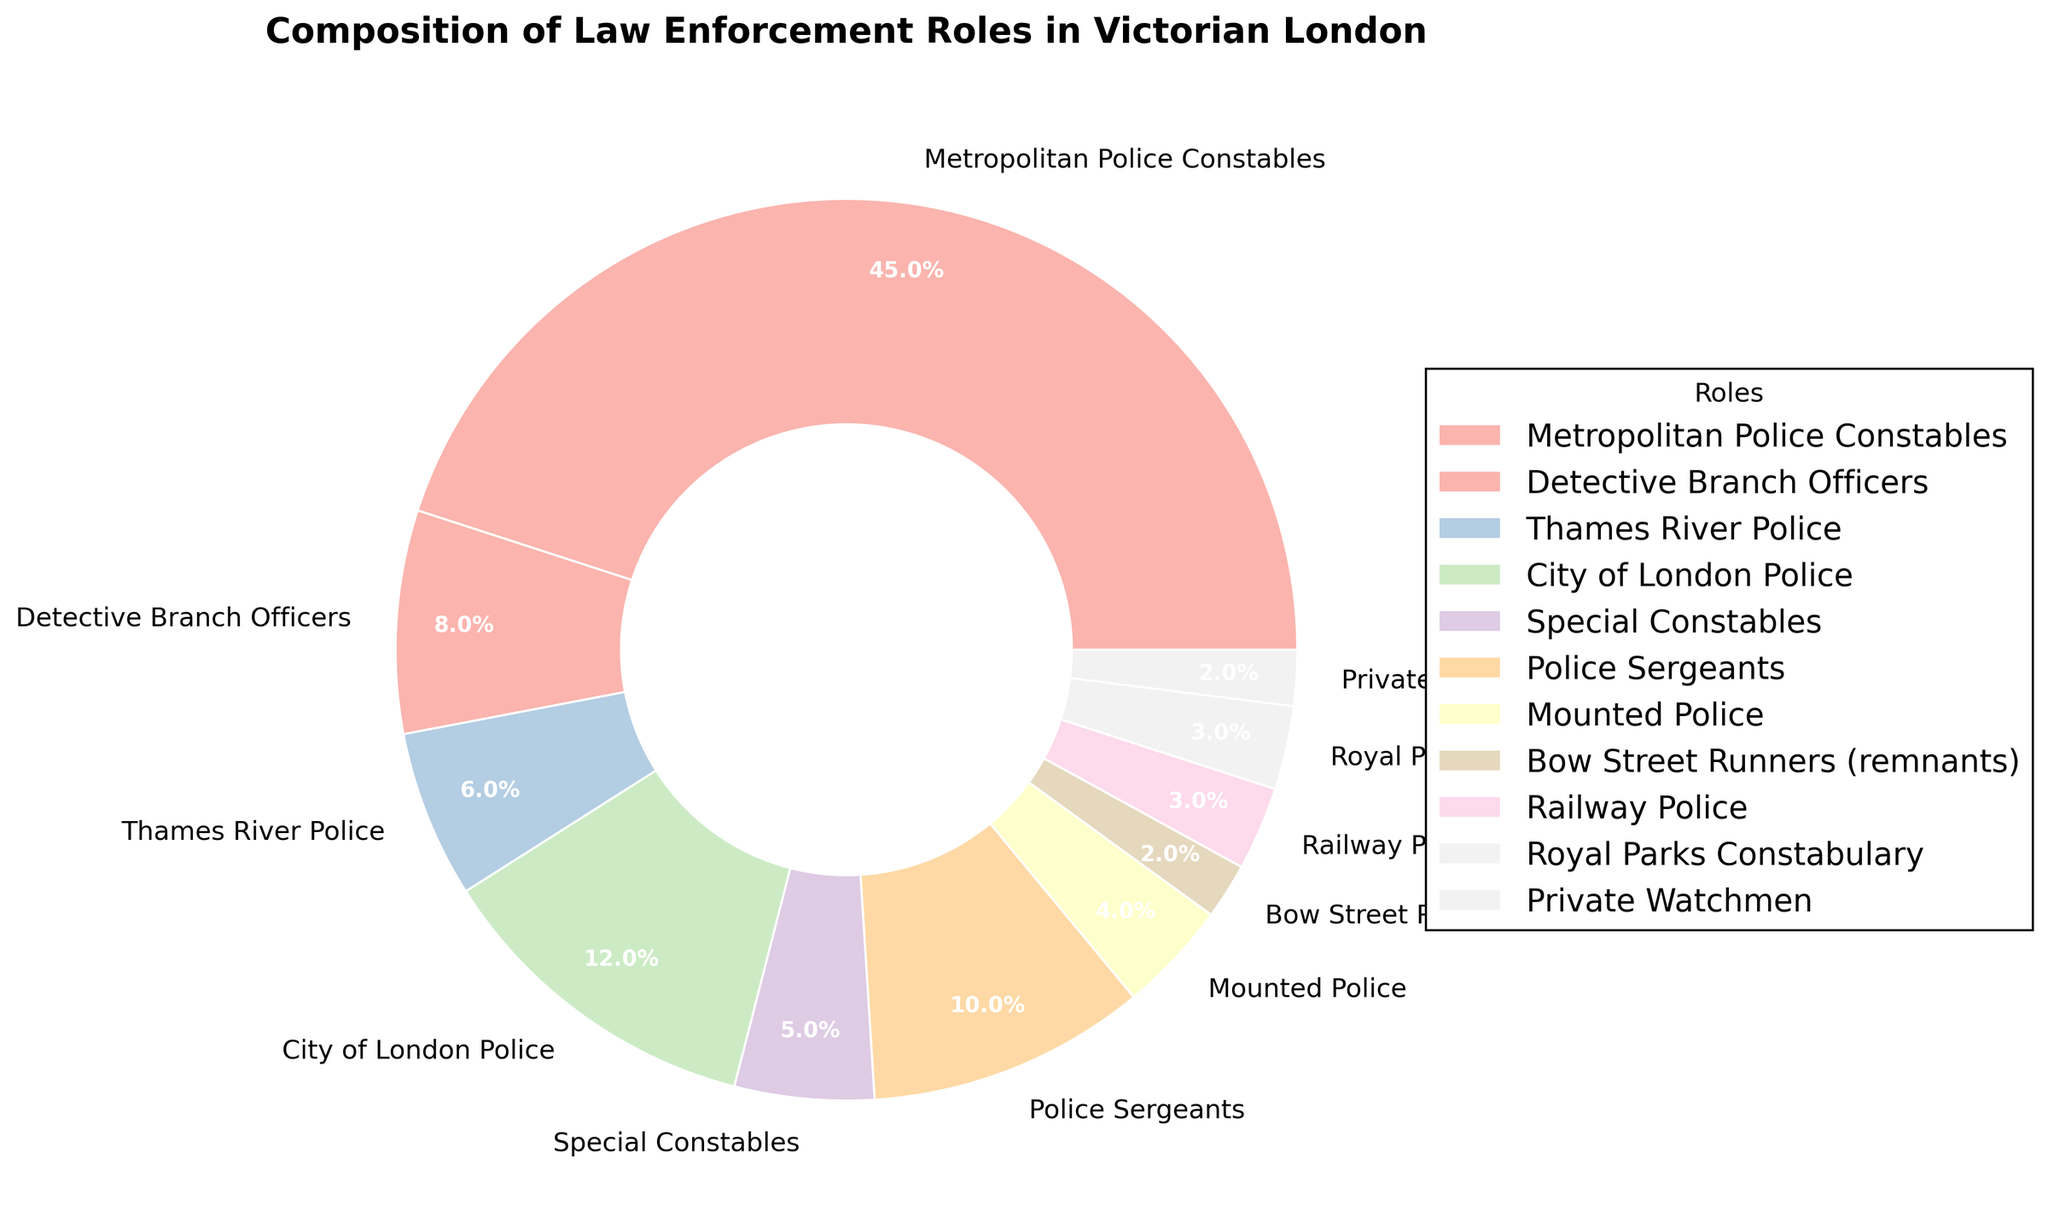What percentage of law enforcement roles do Metropolitan Police Constables and Police Sergeants together constitute? Combine the percentages of Metropolitan Police Constables (45%) and Police Sergeants (10%). Sum them up: 45% + 10% = 55%.
Answer: 55% Which role has the smallest proportion in the chart? How much is it? Identify the role with the smallest percentage, which is Bow Street Runners (remnants) with 2%.
Answer: Bow Street Runners (remnants), 2% How does the percentage of City of London Police compare to that of Thames River Police? The percentage for City of London Police is 12%, and for Thames River Police, it is 6%. Comparatively, City of London Police is twice that of Thames River Police: 12% > 6%.
Answer: City of London Police is twice the percentage of Thames River Police What is the difference in percentage between Detective Branch Officers and Special Constables? Subtract the percentage of Special Constables (5%) from Detective Branch Officers (8%). Difference: 8% - 5% = 3%.
Answer: 3% Which role has a higher percentage: Railway Police or Royal Parks Constabulary? Compare the percentages of Railway Police and Royal Parks Constabulary, both of which have 3%. Thus, they are equal.
Answer: They are equal What is the total percentage of all roles that constitute less than 5% each? Sum the percentages of roles with less than 5% each: Thames River Police (6%), Special Constables (5%), Mounted Police (4%), Bow Street Runners (remnants) (2%), Railway Police (3%), Royal Parks Constabulary (3%), Private Watchmen (2%). Sum: 2% + 3% + 2% = 7%. 6% and 5% are not included as they're not less than 5%.
Answer: 10% What is the average percentage of the Detective Branch Officers, Thames River Police, and City of London Police? Sum the percentages of these roles: Detective Branch Officers (8%), Thames River Police (6%), City of London Police (12%). Then, divide by the number of roles (3). Average: (8% + 6% + 12%) / 3 = 26% / 3 ≈ 8.67%.
Answer: 8.67% What is the most visually dominant segment on the pie chart based on size? The segment with the largest percentage looks visually dominant. Here, it is the Metropolitan Police Constables with 45%.
Answer: Metropolitan Police Constables 